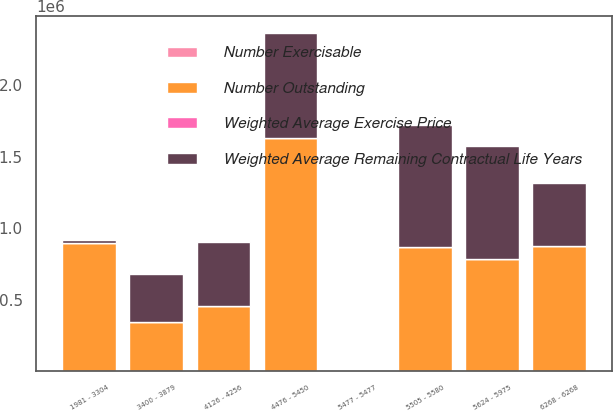Convert chart to OTSL. <chart><loc_0><loc_0><loc_500><loc_500><stacked_bar_chart><ecel><fcel>1981 - 3304<fcel>3400 - 3879<fcel>4126 - 4256<fcel>4476 - 5450<fcel>5477 - 5477<fcel>5505 - 5580<fcel>5624 - 5975<fcel>6268 - 6268<nl><fcel>Number Outstanding<fcel>898734<fcel>345821<fcel>453826<fcel>1.63238e+06<fcel>59.605<fcel>867856<fcel>788392<fcel>875250<nl><fcel>Number Exercisable<fcel>5.06<fcel>2.02<fcel>0.65<fcel>4.69<fcel>1.34<fcel>2.01<fcel>3.91<fcel>4.12<nl><fcel>Weighted Average Exercise Price<fcel>23.51<fcel>37.52<fcel>41.27<fcel>45.92<fcel>54.77<fcel>55.49<fcel>56.53<fcel>62.68<nl><fcel>Weighted Average Remaining Contractual Life Years<fcel>20085<fcel>332538<fcel>452960<fcel>733968<fcel>59.605<fcel>856637<fcel>785346<fcel>442626<nl></chart> 